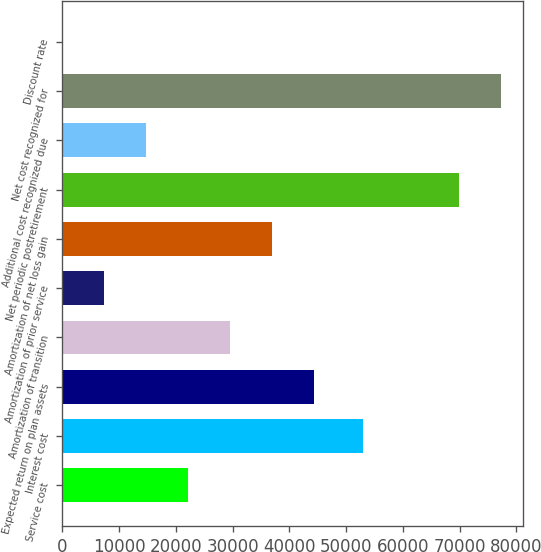Convert chart to OTSL. <chart><loc_0><loc_0><loc_500><loc_500><bar_chart><fcel>Service cost<fcel>Interest cost<fcel>Expected return on plan assets<fcel>Amortization of transition<fcel>Amortization of prior service<fcel>Amortization of net loss gain<fcel>Net periodic postretirement<fcel>Additional cost recognized due<fcel>Net cost recognized for<fcel>Discount rate<nl><fcel>22134.7<fcel>52939<fcel>44263.7<fcel>29511.1<fcel>7382.08<fcel>36887.4<fcel>69878<fcel>14758.4<fcel>77254.3<fcel>5.75<nl></chart> 